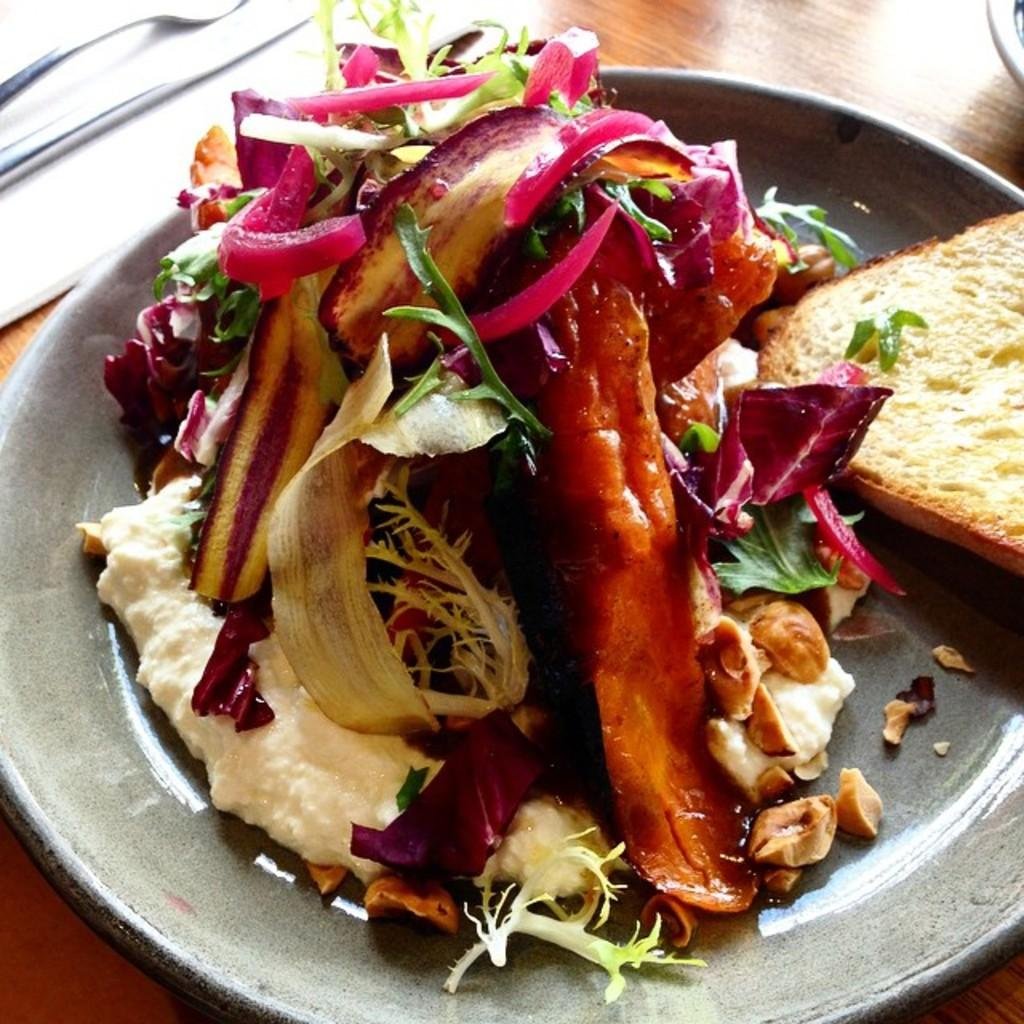What type of surface is visible in the image? There is a wooden surface in the image. What is on the wooden surface? There is a plate with food and a knife on the wooden surface. Can you tell me how much salt is on the wooden surface in the image? There is no salt mentioned or visible in the image. 